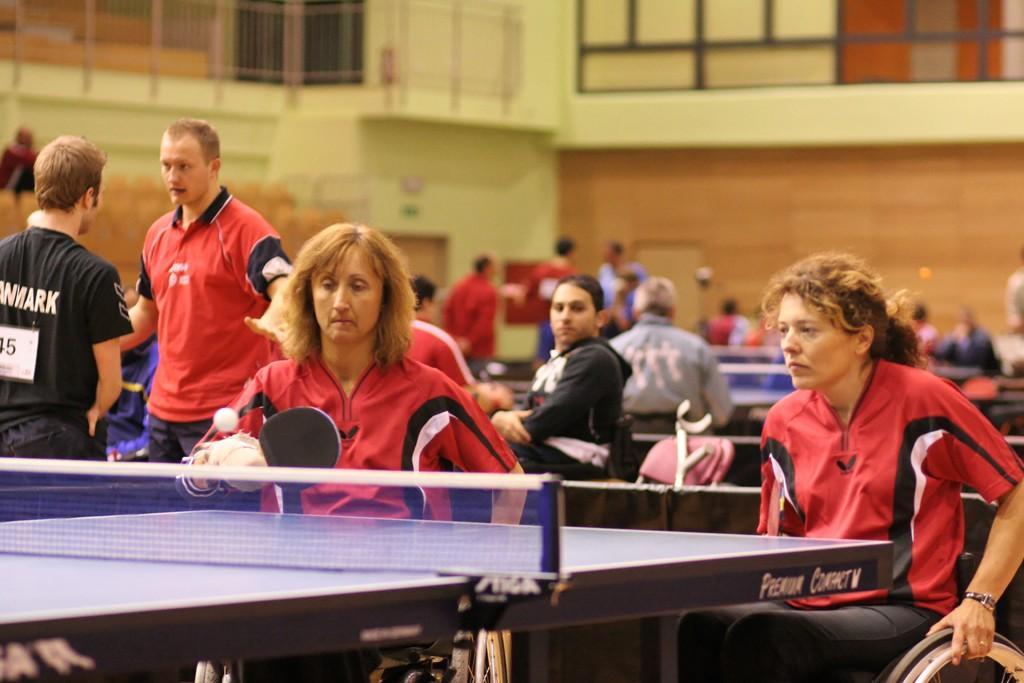How would you summarize this image in a sentence or two? In this image, there are group of people sitting on the wheelchair and playing table tennis. In the background, there is a building of white and brown in color. This image is taken during day time in play court area. 